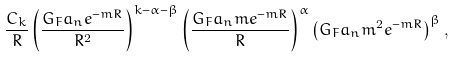<formula> <loc_0><loc_0><loc_500><loc_500>\frac { C _ { k } } { R } \left ( \frac { G _ { F } a _ { n } e ^ { - m R } } { R ^ { 2 } } \right ) ^ { k - \alpha - \beta } \left ( \frac { G _ { F } a _ { n } m e ^ { - m R } } { R } \right ) ^ { \alpha } \left ( G _ { F } a _ { n } m ^ { 2 } e ^ { - m R } \right ) ^ { \beta } ,</formula> 